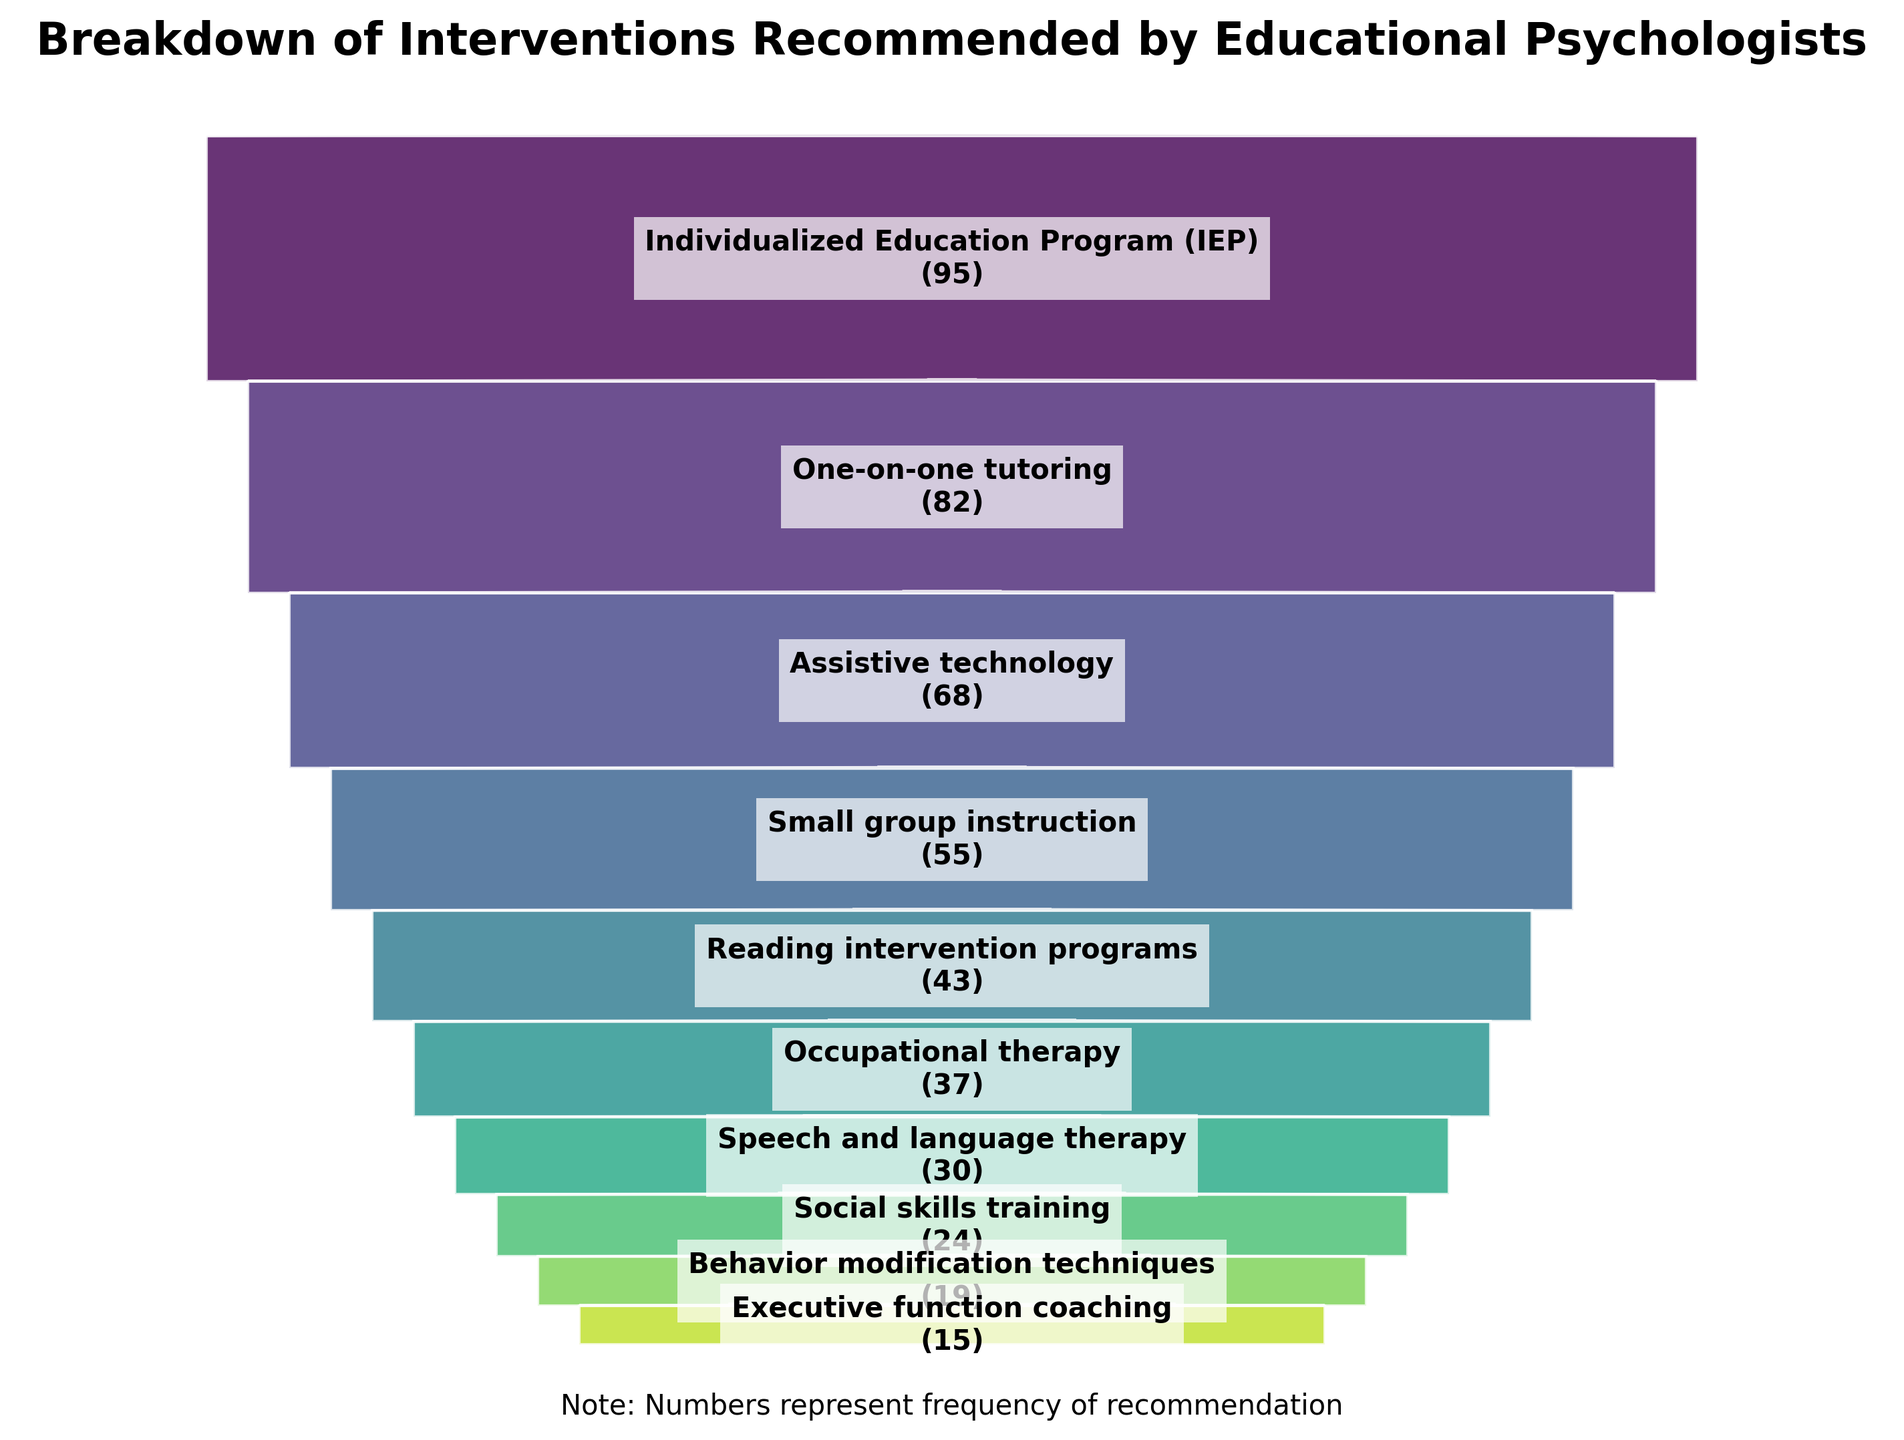What's the title of the figure? The title is the main heading of the figure, usually displayed at the top. It summarizes what the figure represents. In this case, the title states, "Breakdown of Interventions Recommended by Educational Psychologists."
Answer: Breakdown of Interventions Recommended by Educational Psychologists Which intervention is recommended most frequently? To determine the most frequently recommended intervention, look at the widest section at the top of the funnel chart, which indicates the highest frequency. Here, the widest section belongs to "Individualized Education Program (IEP)" with 95 recommendations.
Answer: Individualized Education Program (IEP) How many times is speech and language therapy recommended? The figure includes text labels for each intervention segment. You need to locate the "Speech and language therapy" label on the chart, which shows "30" in parentheses. This indicates that it was recommended 30 times.
Answer: 30 What is the total number of interventions recommended? To find the total number of interventions, you need to sum the frequency of all listed interventions. Adding up all the values: 95 + 82 + 68 + 55 + 43 + 37 + 30 + 24 + 19 + 15 = 468.
Answer: 468 Compare the recommendations for one-on-one tutoring and social skills training. Which one is recommended more often and by how much? First, find the frequencies of both interventions from the figure: "One-on-one tutoring" is 82, and "Social skills training" is 24. Subtract the smaller frequency from the larger one to get the difference: 82 - 24 = 58. One-on-one tutoring is recommended 58 times more than social skills training.
Answer: One-on-one tutoring by 58 What percentage of the total recommendations does the individualized education program (IEP) represent? Calculate the percentage using the formula (frequency of IEP / total frequencies) * 100. The IEP frequency is 95 and the total frequency is 468. So, (95 / 468) * 100 ≈ 20.3%.
Answer: Approximately 20.3% Which intervention is the least recommended and how many times is it recommended? The least recommended intervention will be at the narrowest part of the funnel at the bottom. Here, it shows that "Executive function coaching" is the narrowest part and it is recommended 15 times.
Answer: Executive function coaching, 15 What is the difference in frequency between reading intervention programs and occupational therapy? From the figure, find the frequencies: Reading intervention programs are 43, and occupational therapy is 37. The difference is calculated by subtracting the smaller number from the larger one: 43 - 37 = 6.
Answer: 6 If you combine the recommendations for assistive technology and small group instruction, what is their total frequency? Add the frequencies of assistive technology and small group instruction: 68 (assistive technology) + 55 (small group instruction) = 123.
Answer: 123 Compare small group instruction and behavior modification techniques in terms of frequency. How many more times is small group instruction recommended than behavior modification techniques? Locate their frequencies: Small group instruction is recommended 55 times, and behavior modification techniques are recommended 19 times. Subtract the smaller frequency from the larger one: 55 - 19 = 36. Small group instruction is recommended 36 more times than behavior modification techniques.
Answer: 36 